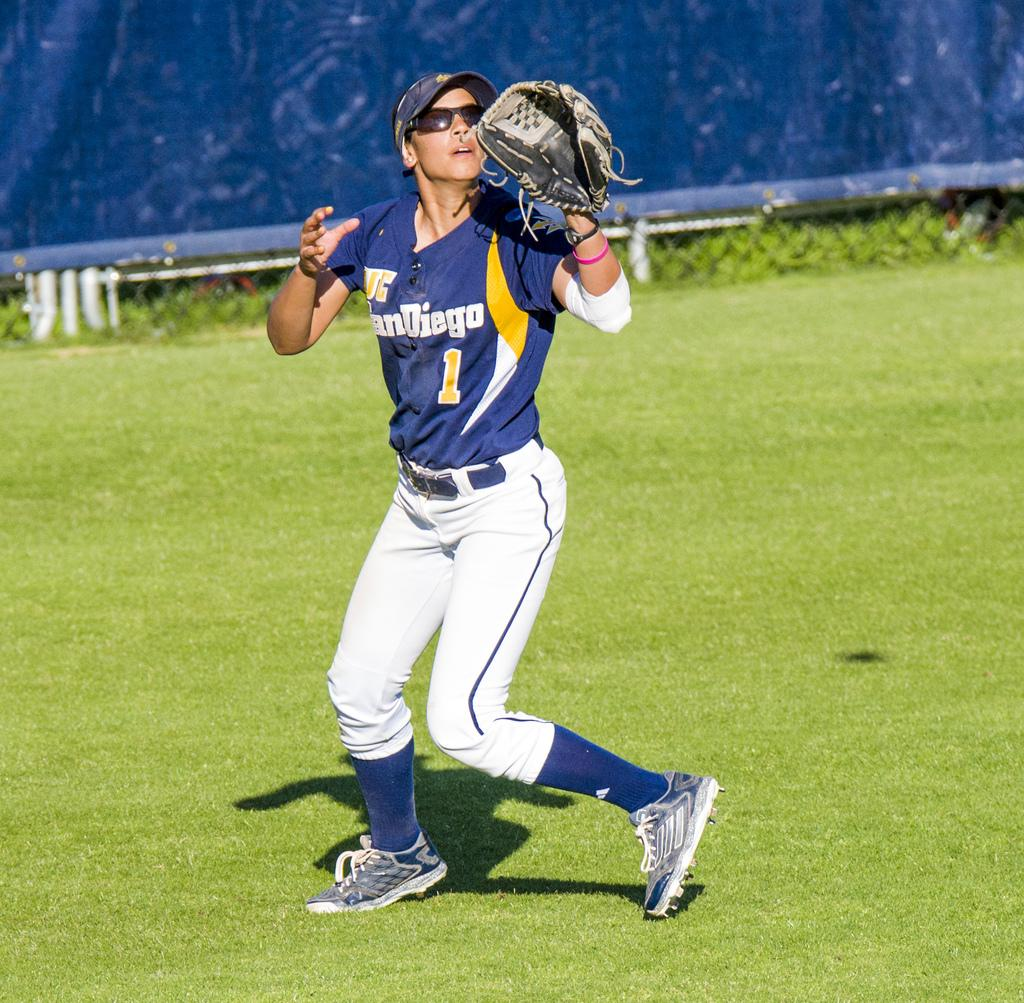<image>
Summarize the visual content of the image. a person with a San Diego jersey on themselves 